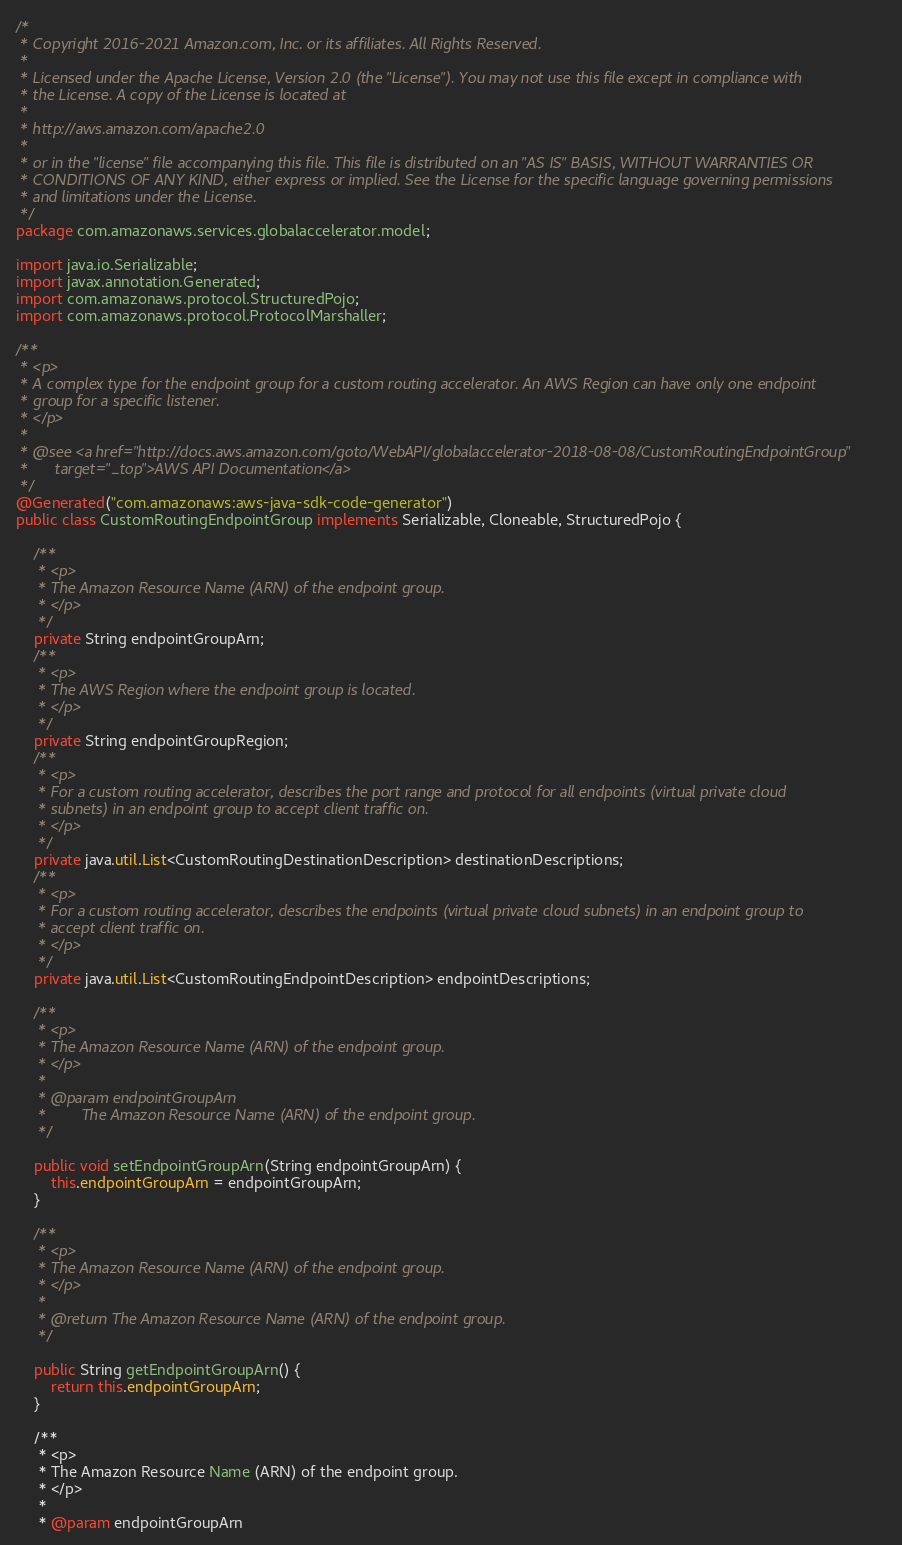<code> <loc_0><loc_0><loc_500><loc_500><_Java_>/*
 * Copyright 2016-2021 Amazon.com, Inc. or its affiliates. All Rights Reserved.
 * 
 * Licensed under the Apache License, Version 2.0 (the "License"). You may not use this file except in compliance with
 * the License. A copy of the License is located at
 * 
 * http://aws.amazon.com/apache2.0
 * 
 * or in the "license" file accompanying this file. This file is distributed on an "AS IS" BASIS, WITHOUT WARRANTIES OR
 * CONDITIONS OF ANY KIND, either express or implied. See the License for the specific language governing permissions
 * and limitations under the License.
 */
package com.amazonaws.services.globalaccelerator.model;

import java.io.Serializable;
import javax.annotation.Generated;
import com.amazonaws.protocol.StructuredPojo;
import com.amazonaws.protocol.ProtocolMarshaller;

/**
 * <p>
 * A complex type for the endpoint group for a custom routing accelerator. An AWS Region can have only one endpoint
 * group for a specific listener.
 * </p>
 * 
 * @see <a href="http://docs.aws.amazon.com/goto/WebAPI/globalaccelerator-2018-08-08/CustomRoutingEndpointGroup"
 *      target="_top">AWS API Documentation</a>
 */
@Generated("com.amazonaws:aws-java-sdk-code-generator")
public class CustomRoutingEndpointGroup implements Serializable, Cloneable, StructuredPojo {

    /**
     * <p>
     * The Amazon Resource Name (ARN) of the endpoint group.
     * </p>
     */
    private String endpointGroupArn;
    /**
     * <p>
     * The AWS Region where the endpoint group is located.
     * </p>
     */
    private String endpointGroupRegion;
    /**
     * <p>
     * For a custom routing accelerator, describes the port range and protocol for all endpoints (virtual private cloud
     * subnets) in an endpoint group to accept client traffic on.
     * </p>
     */
    private java.util.List<CustomRoutingDestinationDescription> destinationDescriptions;
    /**
     * <p>
     * For a custom routing accelerator, describes the endpoints (virtual private cloud subnets) in an endpoint group to
     * accept client traffic on.
     * </p>
     */
    private java.util.List<CustomRoutingEndpointDescription> endpointDescriptions;

    /**
     * <p>
     * The Amazon Resource Name (ARN) of the endpoint group.
     * </p>
     * 
     * @param endpointGroupArn
     *        The Amazon Resource Name (ARN) of the endpoint group.
     */

    public void setEndpointGroupArn(String endpointGroupArn) {
        this.endpointGroupArn = endpointGroupArn;
    }

    /**
     * <p>
     * The Amazon Resource Name (ARN) of the endpoint group.
     * </p>
     * 
     * @return The Amazon Resource Name (ARN) of the endpoint group.
     */

    public String getEndpointGroupArn() {
        return this.endpointGroupArn;
    }

    /**
     * <p>
     * The Amazon Resource Name (ARN) of the endpoint group.
     * </p>
     * 
     * @param endpointGroupArn</code> 